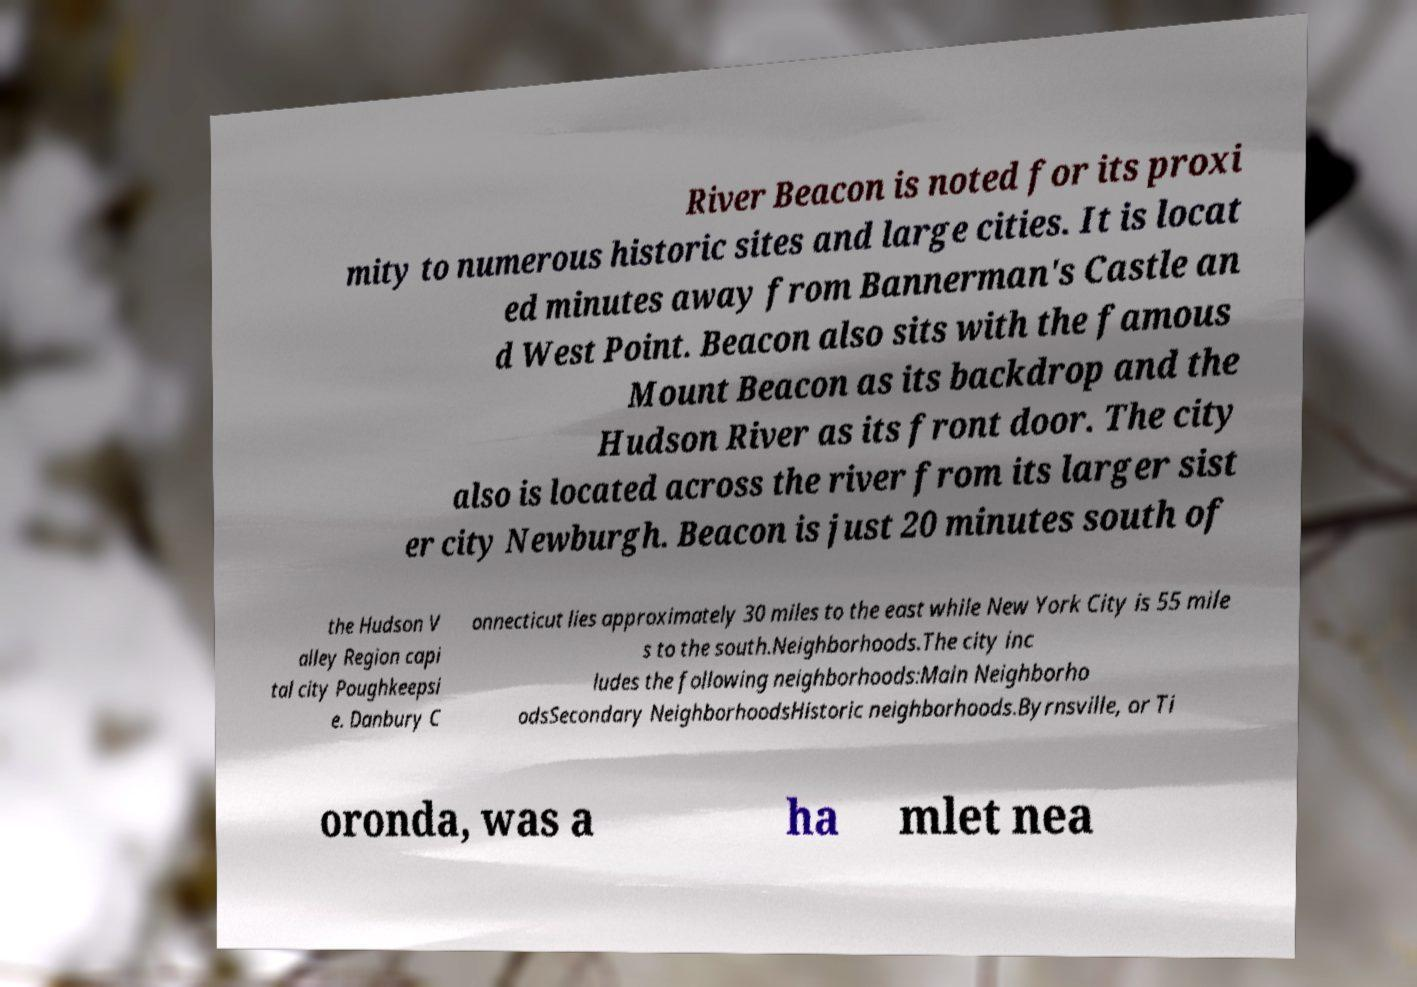Could you assist in decoding the text presented in this image and type it out clearly? River Beacon is noted for its proxi mity to numerous historic sites and large cities. It is locat ed minutes away from Bannerman's Castle an d West Point. Beacon also sits with the famous Mount Beacon as its backdrop and the Hudson River as its front door. The city also is located across the river from its larger sist er city Newburgh. Beacon is just 20 minutes south of the Hudson V alley Region capi tal city Poughkeepsi e. Danbury C onnecticut lies approximately 30 miles to the east while New York City is 55 mile s to the south.Neighborhoods.The city inc ludes the following neighborhoods:Main Neighborho odsSecondary NeighborhoodsHistoric neighborhoods.Byrnsville, or Ti oronda, was a ha mlet nea 